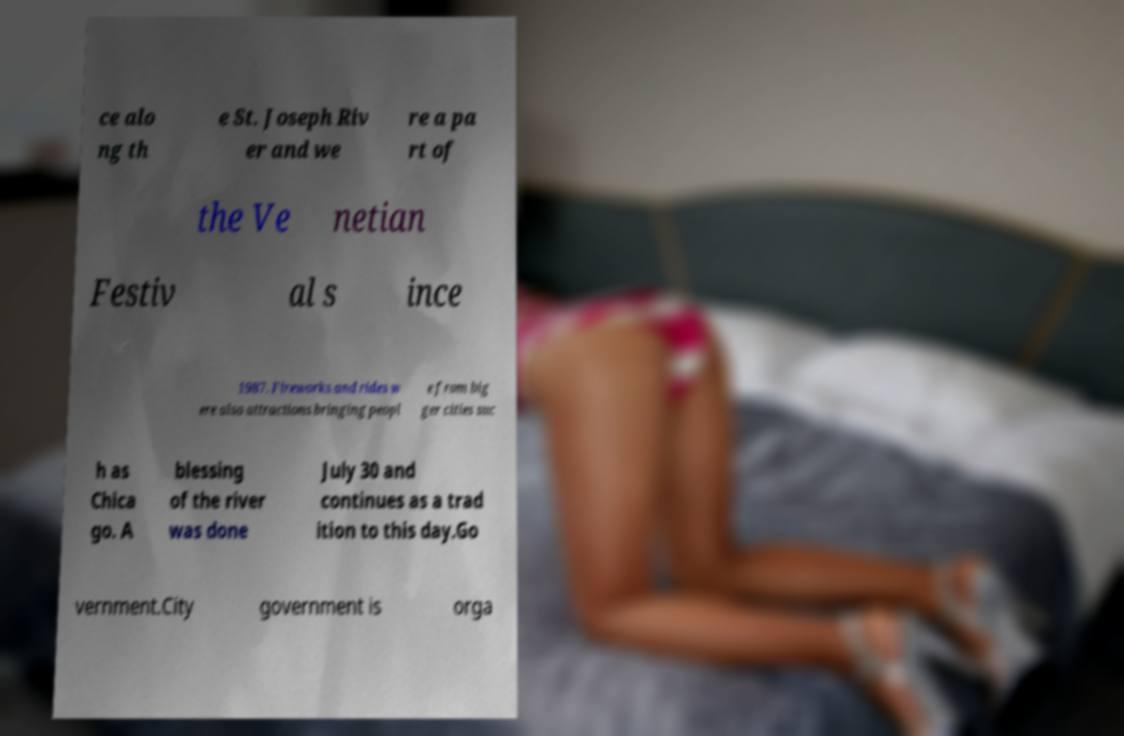Can you read and provide the text displayed in the image?This photo seems to have some interesting text. Can you extract and type it out for me? ce alo ng th e St. Joseph Riv er and we re a pa rt of the Ve netian Festiv al s ince 1987. Fireworks and rides w ere also attractions bringing peopl e from big ger cities suc h as Chica go. A blessing of the river was done July 30 and continues as a trad ition to this day.Go vernment.City government is orga 